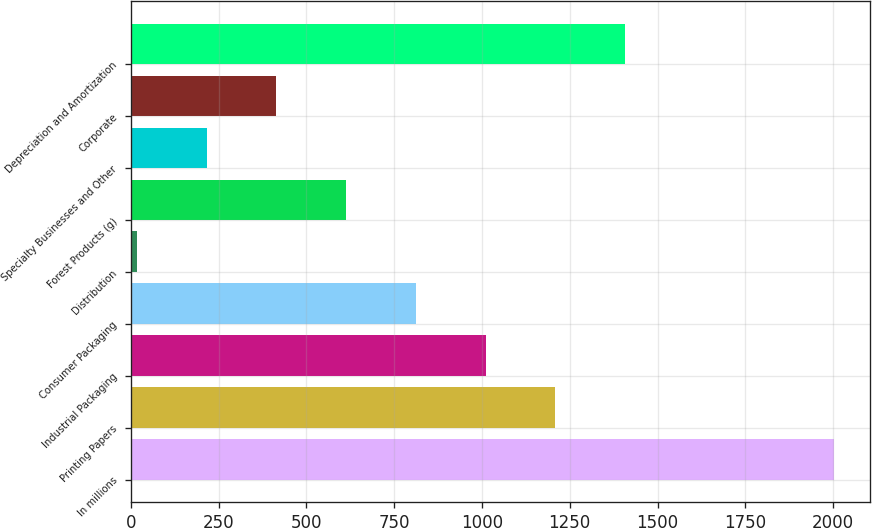<chart> <loc_0><loc_0><loc_500><loc_500><bar_chart><fcel>In millions<fcel>Printing Papers<fcel>Industrial Packaging<fcel>Consumer Packaging<fcel>Distribution<fcel>Forest Products (g)<fcel>Specialty Businesses and Other<fcel>Corporate<fcel>Depreciation and Amortization<nl><fcel>2004<fcel>1209.2<fcel>1010.5<fcel>811.8<fcel>17<fcel>613.1<fcel>215.7<fcel>414.4<fcel>1407.9<nl></chart> 